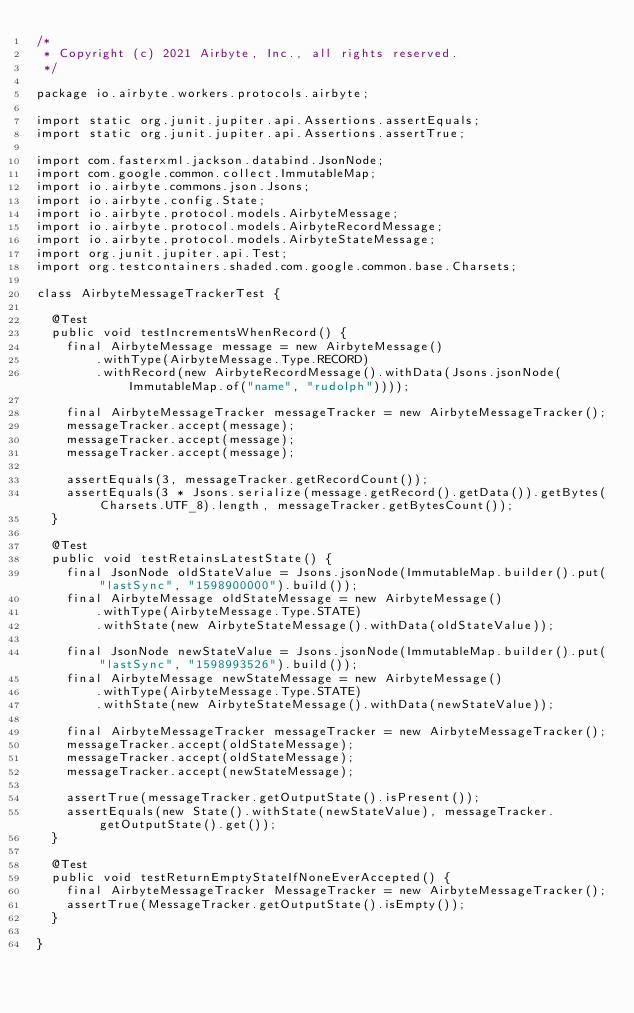Convert code to text. <code><loc_0><loc_0><loc_500><loc_500><_Java_>/*
 * Copyright (c) 2021 Airbyte, Inc., all rights reserved.
 */

package io.airbyte.workers.protocols.airbyte;

import static org.junit.jupiter.api.Assertions.assertEquals;
import static org.junit.jupiter.api.Assertions.assertTrue;

import com.fasterxml.jackson.databind.JsonNode;
import com.google.common.collect.ImmutableMap;
import io.airbyte.commons.json.Jsons;
import io.airbyte.config.State;
import io.airbyte.protocol.models.AirbyteMessage;
import io.airbyte.protocol.models.AirbyteRecordMessage;
import io.airbyte.protocol.models.AirbyteStateMessage;
import org.junit.jupiter.api.Test;
import org.testcontainers.shaded.com.google.common.base.Charsets;

class AirbyteMessageTrackerTest {

  @Test
  public void testIncrementsWhenRecord() {
    final AirbyteMessage message = new AirbyteMessage()
        .withType(AirbyteMessage.Type.RECORD)
        .withRecord(new AirbyteRecordMessage().withData(Jsons.jsonNode(ImmutableMap.of("name", "rudolph"))));

    final AirbyteMessageTracker messageTracker = new AirbyteMessageTracker();
    messageTracker.accept(message);
    messageTracker.accept(message);
    messageTracker.accept(message);

    assertEquals(3, messageTracker.getRecordCount());
    assertEquals(3 * Jsons.serialize(message.getRecord().getData()).getBytes(Charsets.UTF_8).length, messageTracker.getBytesCount());
  }

  @Test
  public void testRetainsLatestState() {
    final JsonNode oldStateValue = Jsons.jsonNode(ImmutableMap.builder().put("lastSync", "1598900000").build());
    final AirbyteMessage oldStateMessage = new AirbyteMessage()
        .withType(AirbyteMessage.Type.STATE)
        .withState(new AirbyteStateMessage().withData(oldStateValue));

    final JsonNode newStateValue = Jsons.jsonNode(ImmutableMap.builder().put("lastSync", "1598993526").build());
    final AirbyteMessage newStateMessage = new AirbyteMessage()
        .withType(AirbyteMessage.Type.STATE)
        .withState(new AirbyteStateMessage().withData(newStateValue));

    final AirbyteMessageTracker messageTracker = new AirbyteMessageTracker();
    messageTracker.accept(oldStateMessage);
    messageTracker.accept(oldStateMessage);
    messageTracker.accept(newStateMessage);

    assertTrue(messageTracker.getOutputState().isPresent());
    assertEquals(new State().withState(newStateValue), messageTracker.getOutputState().get());
  }

  @Test
  public void testReturnEmptyStateIfNoneEverAccepted() {
    final AirbyteMessageTracker MessageTracker = new AirbyteMessageTracker();
    assertTrue(MessageTracker.getOutputState().isEmpty());
  }

}
</code> 